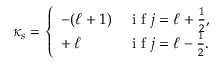Convert formula to latex. <formula><loc_0><loc_0><loc_500><loc_500>\kappa _ { s } = \left \{ \begin{array} { l l } { - ( \ell + 1 ) } & { i f j = \ell + \frac { 1 } { 2 } , } \\ { + \, \ell } & { i f j = \ell - \frac { 1 } { 2 } . } \end{array}</formula> 